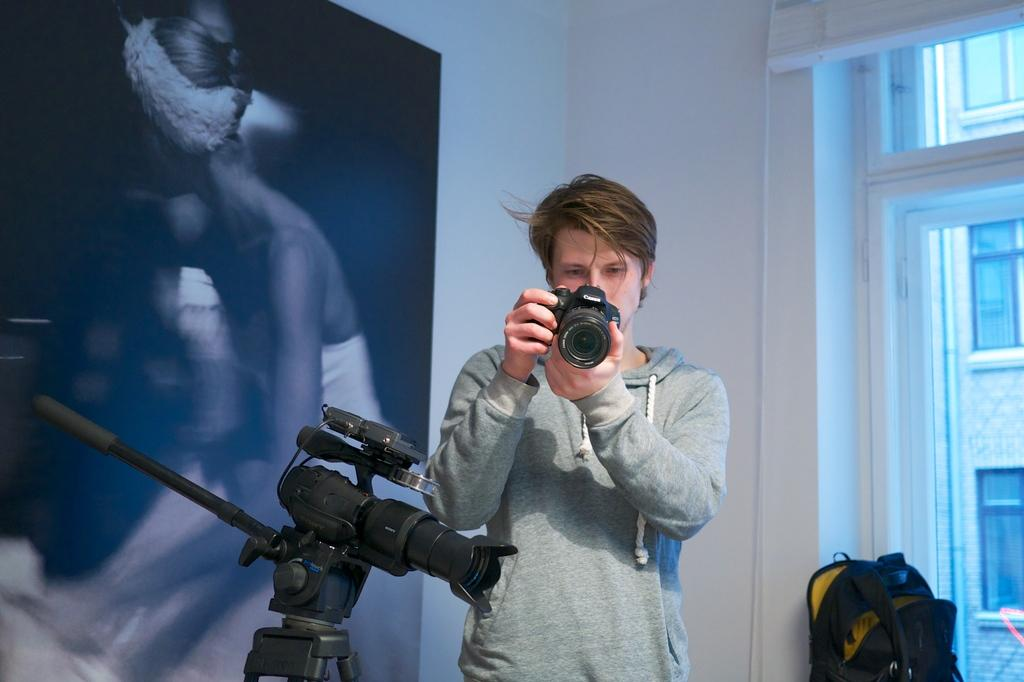What is the man in the image holding? The man is holding a camera. Are there any other cameras visible in the image? Yes, there is another camera on the man's left side. What is on the man's right side? There is a bag on the man's right side. What can be seen in the background of the image? There is a window and a photo on the wall in the background of the image. What type of potato is being used as a prop in the image? There is no potato present in the image. What type of produce is being displayed on the wall in the image? There is no produce displayed on the wall in the image; there is a photo on the wall. 